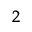Convert formula to latex. <formula><loc_0><loc_0><loc_500><loc_500>_ { 2 }</formula> 